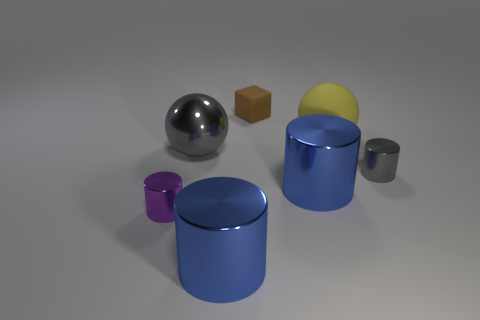There is a purple thing that is the same size as the block; what is it made of?
Your answer should be very brief. Metal. There is a tiny brown rubber thing; are there any brown matte objects in front of it?
Give a very brief answer. No. Are there the same number of gray metal cylinders that are in front of the big rubber sphere and large yellow spheres?
Your answer should be very brief. Yes. What shape is the purple metal thing that is the same size as the brown rubber block?
Your response must be concise. Cylinder. What is the material of the brown object?
Your answer should be very brief. Rubber. What is the color of the shiny cylinder that is both to the right of the tiny rubber cube and in front of the small gray thing?
Offer a very short reply. Blue. Are there an equal number of big metallic cylinders that are in front of the small purple object and gray shiny spheres that are right of the tiny gray shiny object?
Your answer should be compact. No. What is the color of the other tiny object that is made of the same material as the purple thing?
Make the answer very short. Gray. Is the color of the shiny ball the same as the tiny cylinder right of the gray sphere?
Keep it short and to the point. Yes. There is a gray object behind the gray object on the right side of the small brown matte object; is there a large sphere behind it?
Offer a terse response. Yes. 